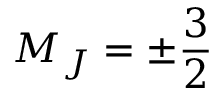Convert formula to latex. <formula><loc_0><loc_0><loc_500><loc_500>M _ { J } = \pm \frac { 3 } { 2 }</formula> 